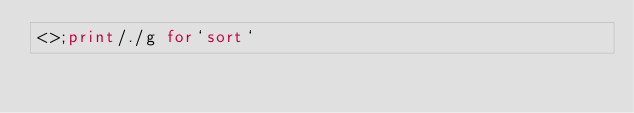Convert code to text. <code><loc_0><loc_0><loc_500><loc_500><_Perl_><>;print/./g for`sort`</code> 